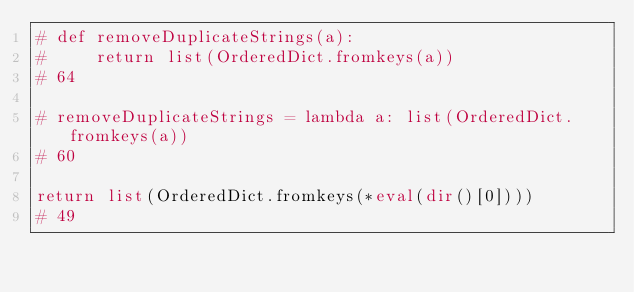Convert code to text. <code><loc_0><loc_0><loc_500><loc_500><_Python_># def removeDuplicateStrings(a):
#     return list(OrderedDict.fromkeys(a))
# 64

# removeDuplicateStrings = lambda a: list(OrderedDict.fromkeys(a))
# 60

return list(OrderedDict.fromkeys(*eval(dir()[0])))
# 49
</code> 